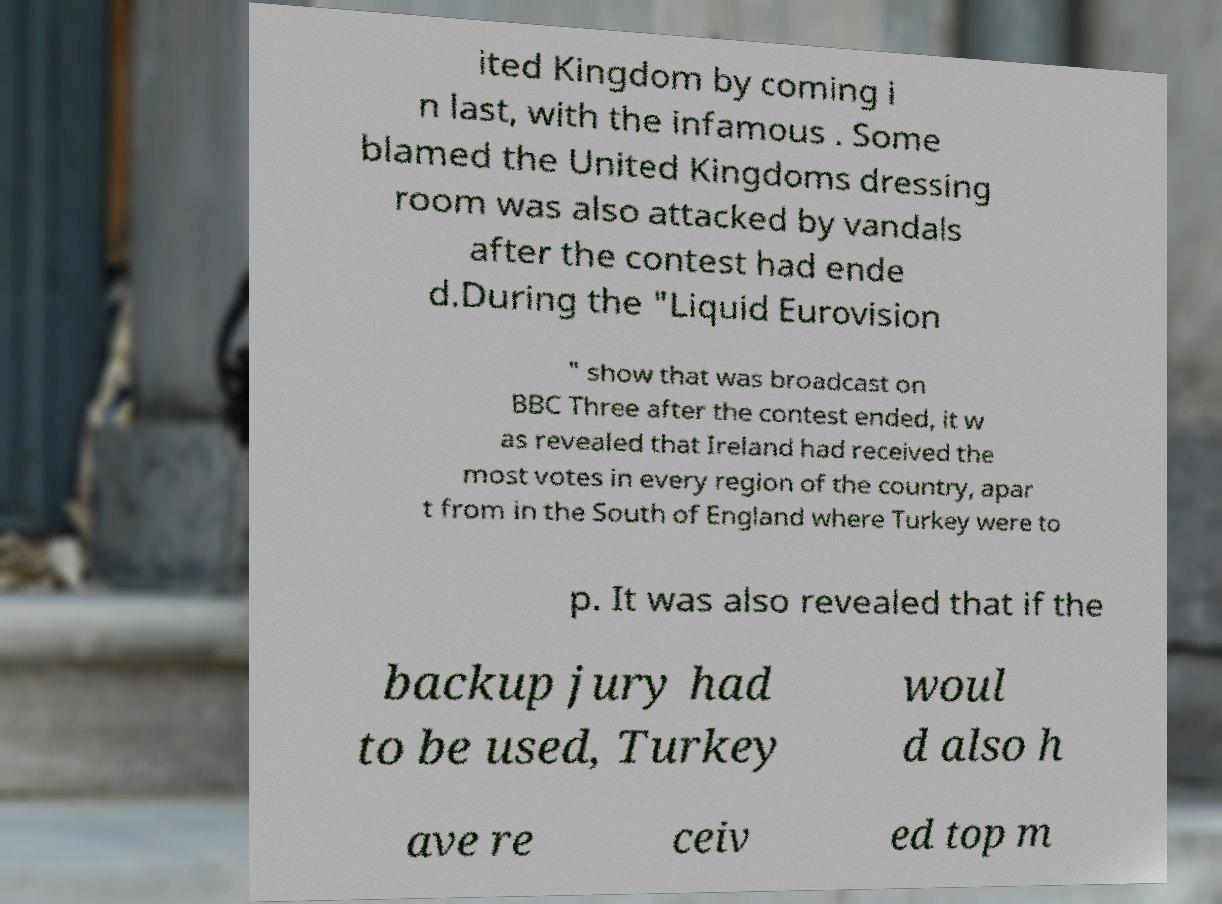Please read and relay the text visible in this image. What does it say? ited Kingdom by coming i n last, with the infamous . Some blamed the United Kingdoms dressing room was also attacked by vandals after the contest had ende d.During the "Liquid Eurovision " show that was broadcast on BBC Three after the contest ended, it w as revealed that Ireland had received the most votes in every region of the country, apar t from in the South of England where Turkey were to p. It was also revealed that if the backup jury had to be used, Turkey woul d also h ave re ceiv ed top m 